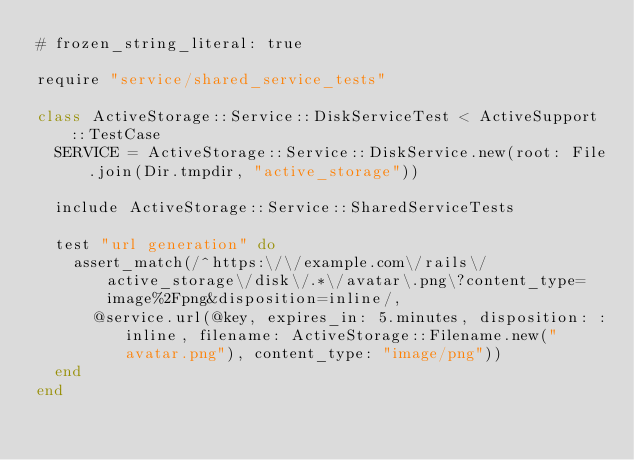Convert code to text. <code><loc_0><loc_0><loc_500><loc_500><_Ruby_># frozen_string_literal: true

require "service/shared_service_tests"

class ActiveStorage::Service::DiskServiceTest < ActiveSupport::TestCase
  SERVICE = ActiveStorage::Service::DiskService.new(root: File.join(Dir.tmpdir, "active_storage"))

  include ActiveStorage::Service::SharedServiceTests

  test "url generation" do
    assert_match(/^https:\/\/example.com\/rails\/active_storage\/disk\/.*\/avatar\.png\?content_type=image%2Fpng&disposition=inline/,
      @service.url(@key, expires_in: 5.minutes, disposition: :inline, filename: ActiveStorage::Filename.new("avatar.png"), content_type: "image/png"))
  end
end
</code> 